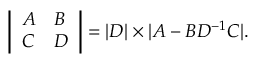Convert formula to latex. <formula><loc_0><loc_0><loc_500><loc_500>\left | \begin{array} { l l } { A } & { B } \\ { C } & { D } \end{array} \right | = | D | \times | A - B D ^ { - 1 } C | .</formula> 